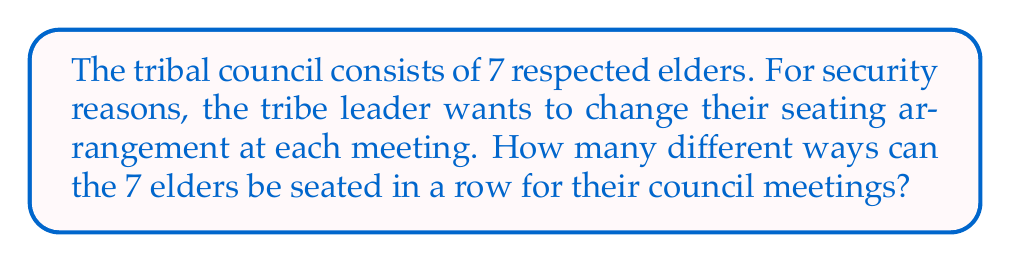Can you answer this question? To solve this problem, we need to use the concept of permutations. A permutation is an arrangement of objects where order matters. In this case, we are arranging 7 elders in a specific order, and each arrangement is considered different.

The number of permutations of n distinct objects is given by the formula:

$$P(n) = n!$$

Where $n!$ (n factorial) is the product of all positive integers less than or equal to n.

In this problem:
1. We have 7 elders to arrange.
2. Each elder is distinct, and the order matters.
3. We are using all 7 elders in each arrangement.

Therefore, we can directly apply the permutation formula:

$$P(7) = 7!$$

Calculating 7!:
$$7! = 7 \times 6 \times 5 \times 4 \times 3 \times 2 \times 1 = 5040$$

Thus, there are 5040 different ways to arrange the 7 tribal elders in a row for their council meetings.
Answer: 5040 